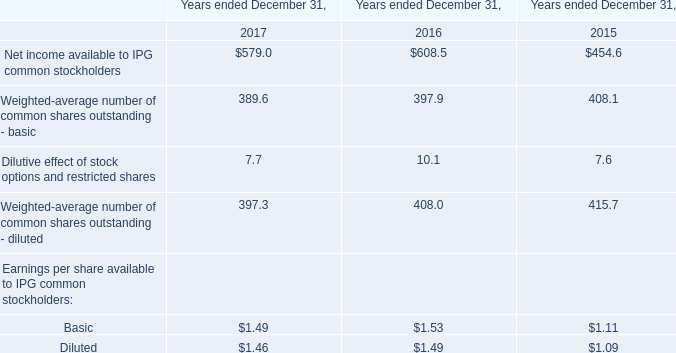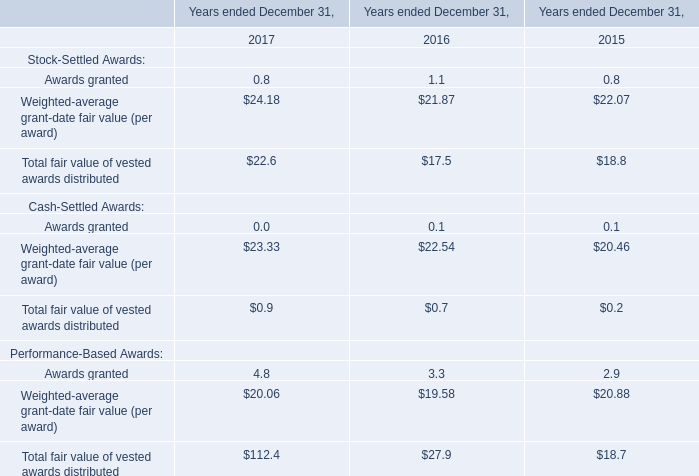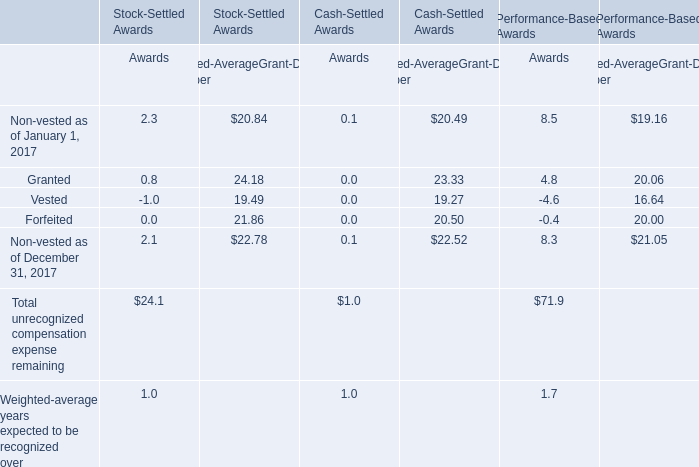what is the highest total amount of unrecognized compensation expense remaining? 
Answer: 71.9. 